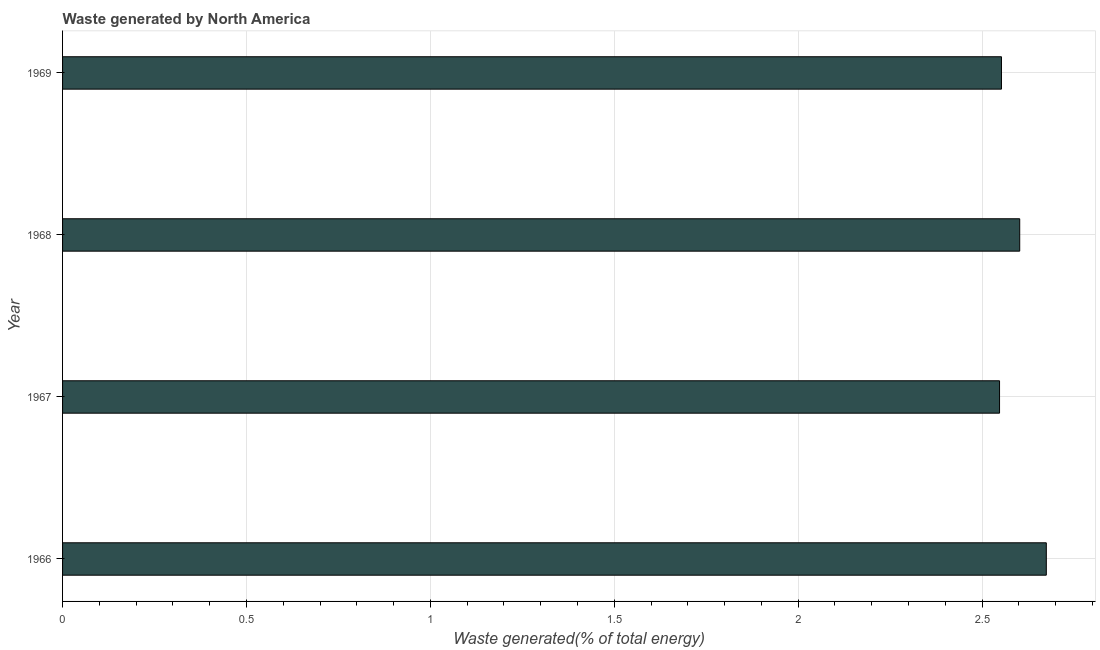What is the title of the graph?
Make the answer very short. Waste generated by North America. What is the label or title of the X-axis?
Your answer should be compact. Waste generated(% of total energy). What is the label or title of the Y-axis?
Ensure brevity in your answer.  Year. What is the amount of waste generated in 1966?
Your response must be concise. 2.67. Across all years, what is the maximum amount of waste generated?
Your response must be concise. 2.67. Across all years, what is the minimum amount of waste generated?
Your answer should be compact. 2.55. In which year was the amount of waste generated maximum?
Make the answer very short. 1966. In which year was the amount of waste generated minimum?
Your answer should be compact. 1967. What is the sum of the amount of waste generated?
Offer a terse response. 10.38. What is the difference between the amount of waste generated in 1966 and 1968?
Offer a very short reply. 0.07. What is the average amount of waste generated per year?
Give a very brief answer. 2.6. What is the median amount of waste generated?
Offer a terse response. 2.58. What is the ratio of the amount of waste generated in 1968 to that in 1969?
Keep it short and to the point. 1.02. What is the difference between the highest and the second highest amount of waste generated?
Provide a succinct answer. 0.07. What is the difference between the highest and the lowest amount of waste generated?
Your response must be concise. 0.13. In how many years, is the amount of waste generated greater than the average amount of waste generated taken over all years?
Provide a short and direct response. 2. How many bars are there?
Offer a terse response. 4. What is the difference between two consecutive major ticks on the X-axis?
Your answer should be compact. 0.5. Are the values on the major ticks of X-axis written in scientific E-notation?
Make the answer very short. No. What is the Waste generated(% of total energy) in 1966?
Make the answer very short. 2.67. What is the Waste generated(% of total energy) in 1967?
Provide a short and direct response. 2.55. What is the Waste generated(% of total energy) in 1968?
Your answer should be very brief. 2.6. What is the Waste generated(% of total energy) in 1969?
Give a very brief answer. 2.55. What is the difference between the Waste generated(% of total energy) in 1966 and 1967?
Ensure brevity in your answer.  0.13. What is the difference between the Waste generated(% of total energy) in 1966 and 1968?
Offer a very short reply. 0.07. What is the difference between the Waste generated(% of total energy) in 1966 and 1969?
Your answer should be compact. 0.12. What is the difference between the Waste generated(% of total energy) in 1967 and 1968?
Provide a short and direct response. -0.05. What is the difference between the Waste generated(% of total energy) in 1967 and 1969?
Give a very brief answer. -0.01. What is the difference between the Waste generated(% of total energy) in 1968 and 1969?
Ensure brevity in your answer.  0.05. What is the ratio of the Waste generated(% of total energy) in 1966 to that in 1968?
Make the answer very short. 1.03. What is the ratio of the Waste generated(% of total energy) in 1966 to that in 1969?
Ensure brevity in your answer.  1.05. What is the ratio of the Waste generated(% of total energy) in 1967 to that in 1968?
Provide a succinct answer. 0.98. 